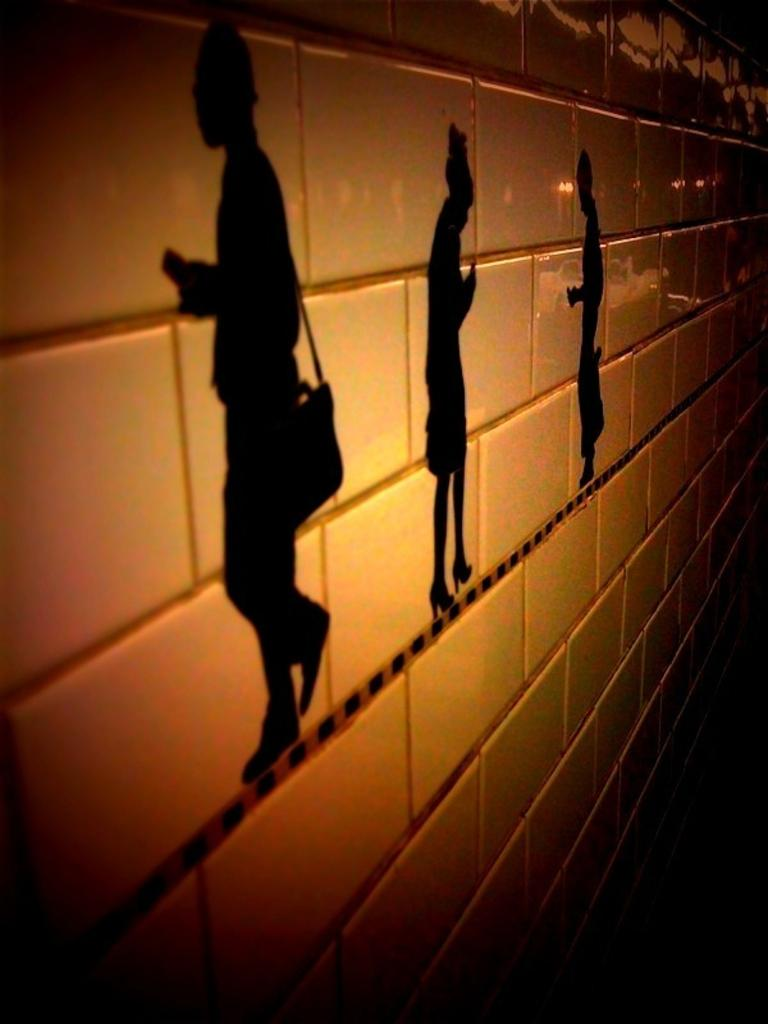What type of structure is visible in the image? There is a brick wall in the image. What is depicted on the brick wall? There is a painting of people on the wall. Can you describe the first person in the painting? The first person in the painting is wearing a bag. What type of produce is being grown on the brick wall in the image? There is no produce being grown on the brick wall in the image; it features a painting of people. 